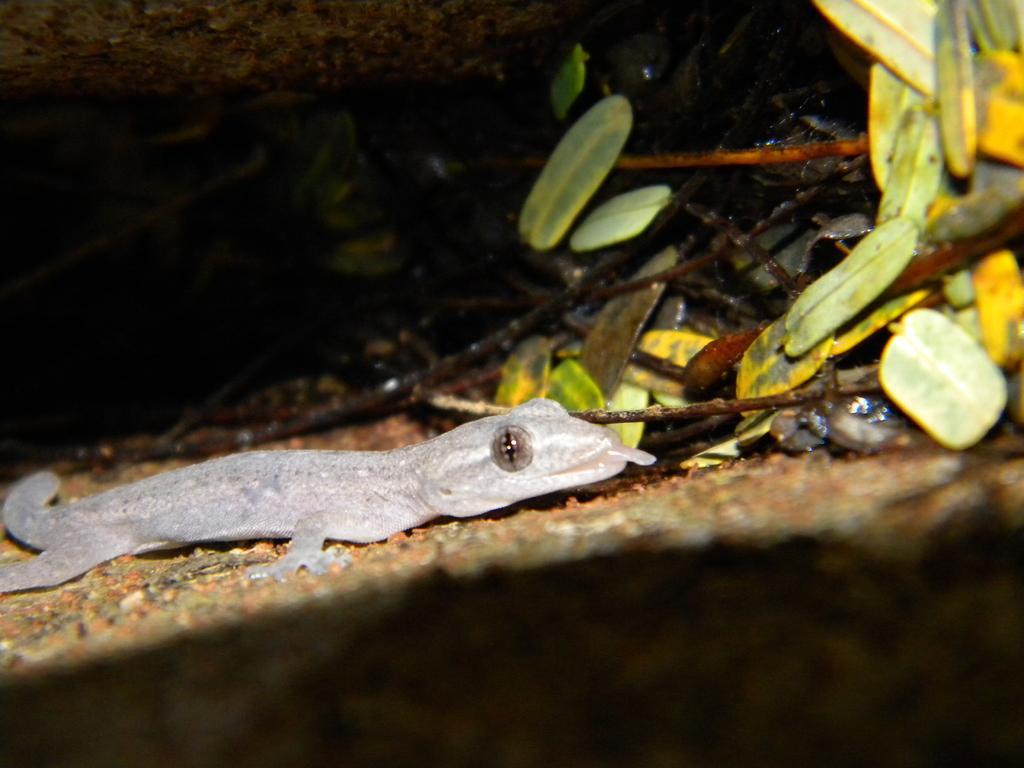Please provide a concise description of this image. In this image, we can see a reptile and in the background, there are leaves and we can see twigs and tree trunks. 